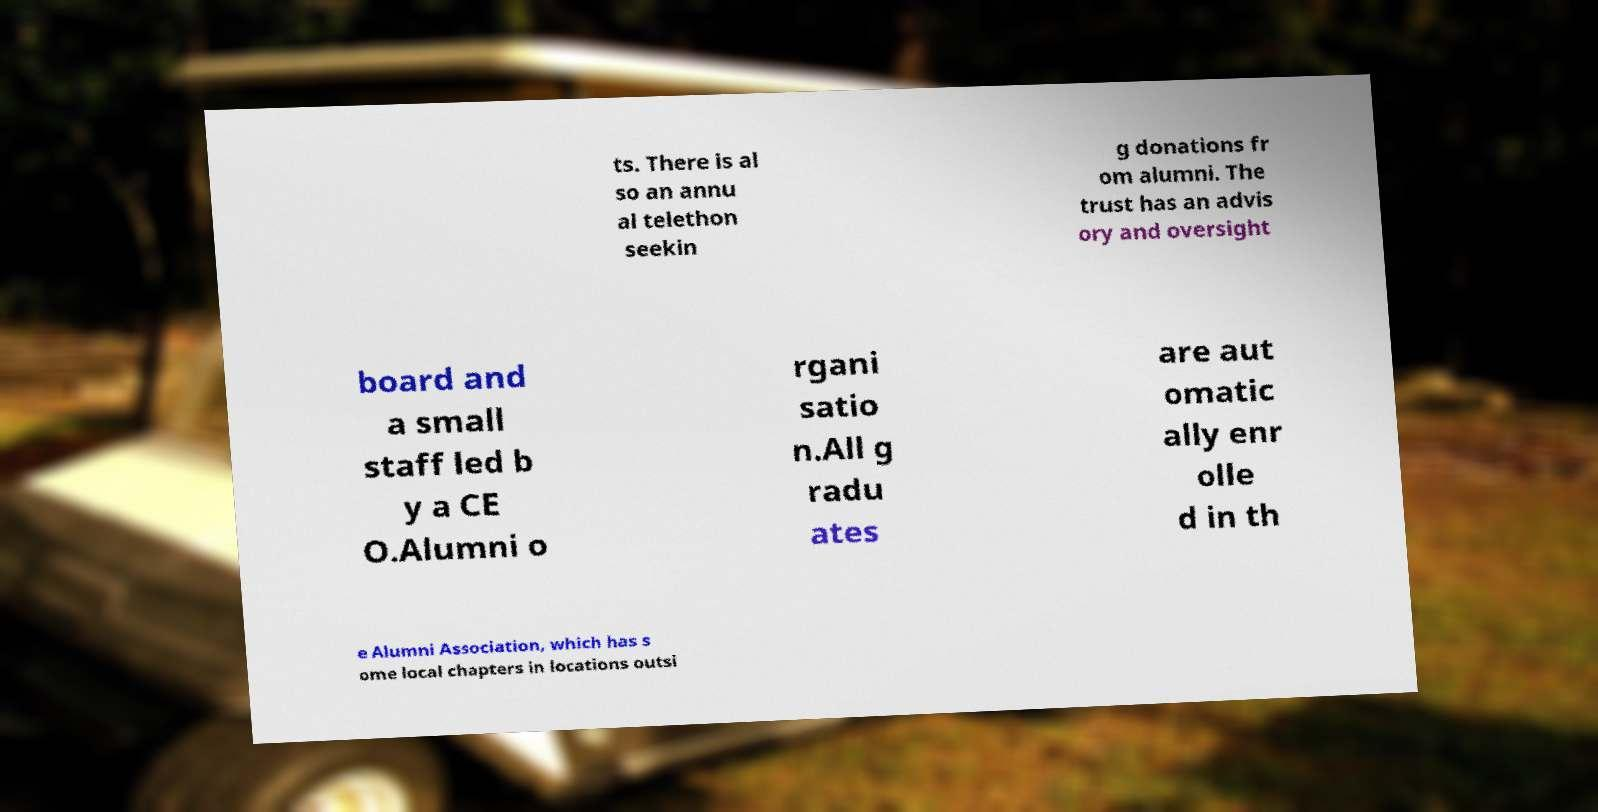There's text embedded in this image that I need extracted. Can you transcribe it verbatim? ts. There is al so an annu al telethon seekin g donations fr om alumni. The trust has an advis ory and oversight board and a small staff led b y a CE O.Alumni o rgani satio n.All g radu ates are aut omatic ally enr olle d in th e Alumni Association, which has s ome local chapters in locations outsi 